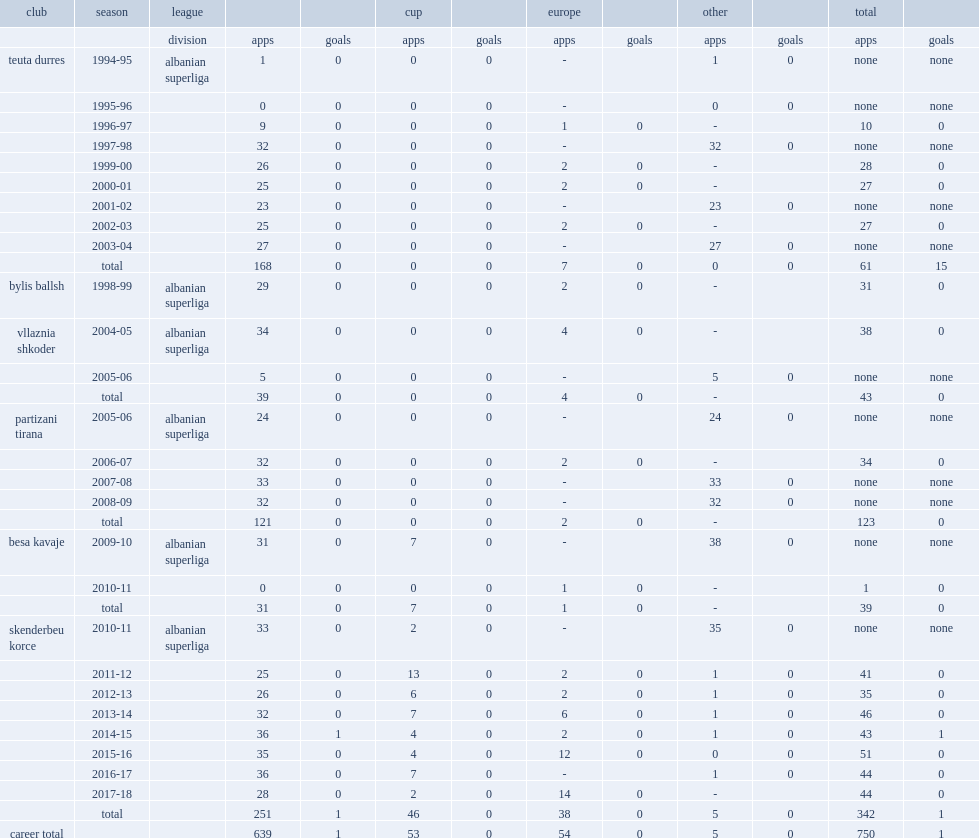Shehi began his career with teuta durres, which league did he make his debut for the club during the 1994-95 campaign? Albanian superliga. 